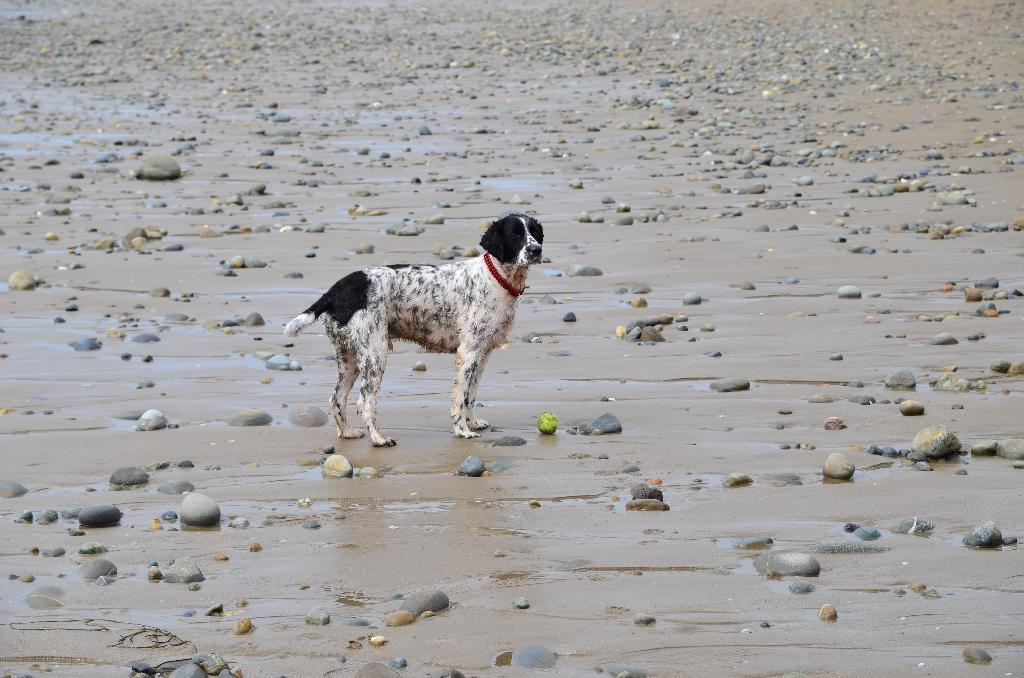What type of terrain is depicted in the image? There is wet sand in the image. What small rocks can be seen in the image? There are pebbles in the image. What animal is present in the image? There is a dog in the image. What is the dog wearing around its neck? The dog has a belt around its neck. What type of basin can be seen in the image? There is no basin present in the image; it features wet sand, pebbles, and a dog. What kind of curve is visible on the dog's lip in the image? There is no mention of the dog's lip in the image, and no curve can be observed on it. 